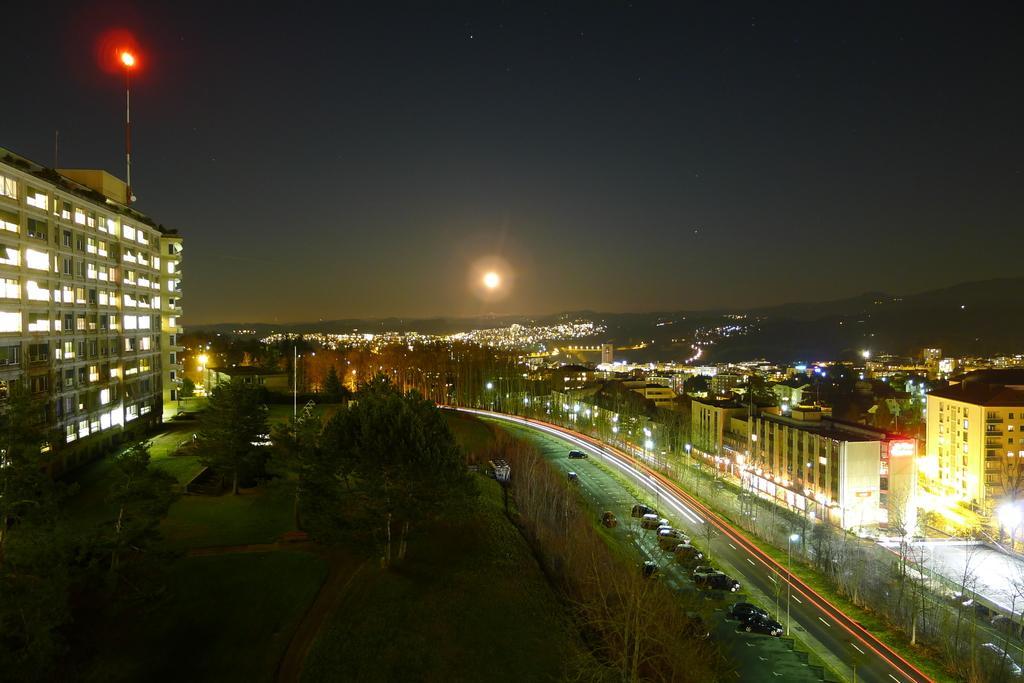In one or two sentences, can you explain what this image depicts? This is an aerial view and here we can see vehicles on the road and in the background, there are buildings, trees, poles, lights. At the top, there is sky and at the bottom, there is a ground. 